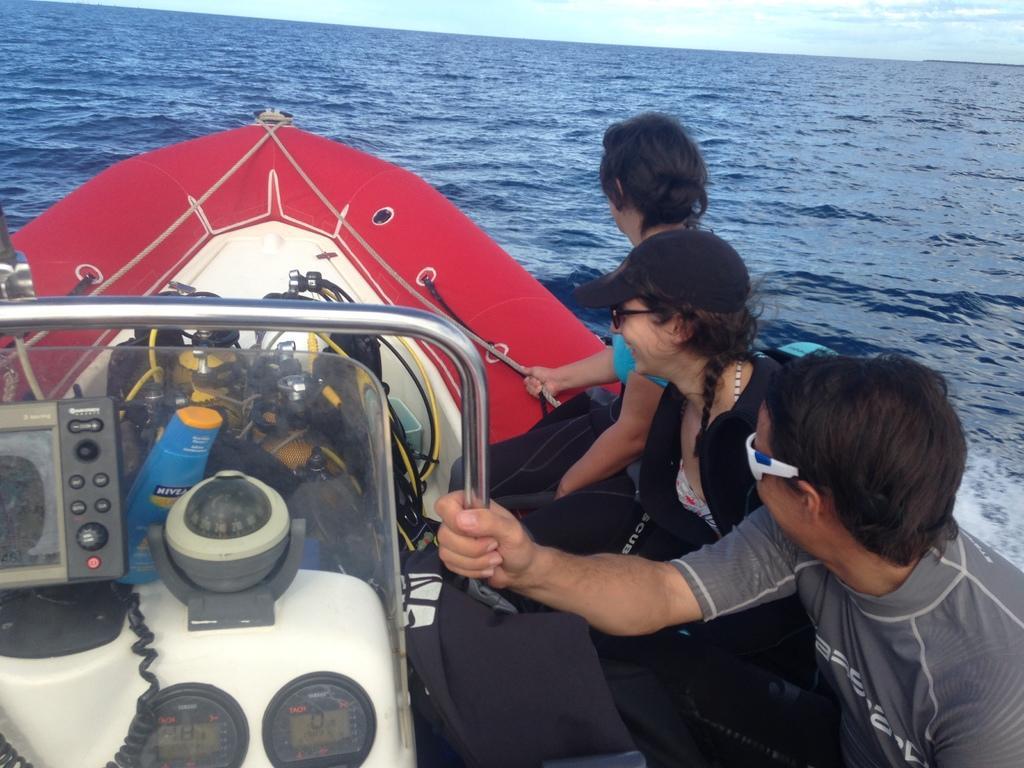Could you give a brief overview of what you see in this image? In this picture we can see there are three people sitting on a boat and the boat is on the water. In front of the boat there is a sky. 